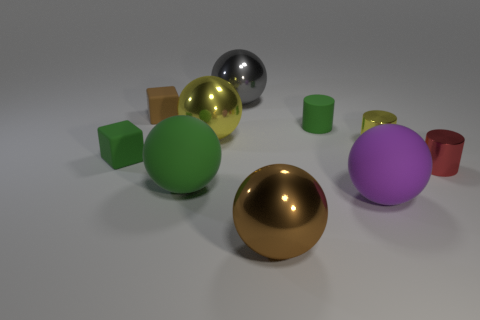What is the lighting setup implied by the reflections on the objects? The lighting setup seems to consist of a soft overhead light that casts gentle shadows beneath the objects, with some minimal reflections indicating the presence of perhaps one or two additional light sources out of the frame. The soft edges of the shadows suggest a diffused light source, enhancing the scene's realistic appearance. 